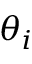Convert formula to latex. <formula><loc_0><loc_0><loc_500><loc_500>\theta _ { i }</formula> 